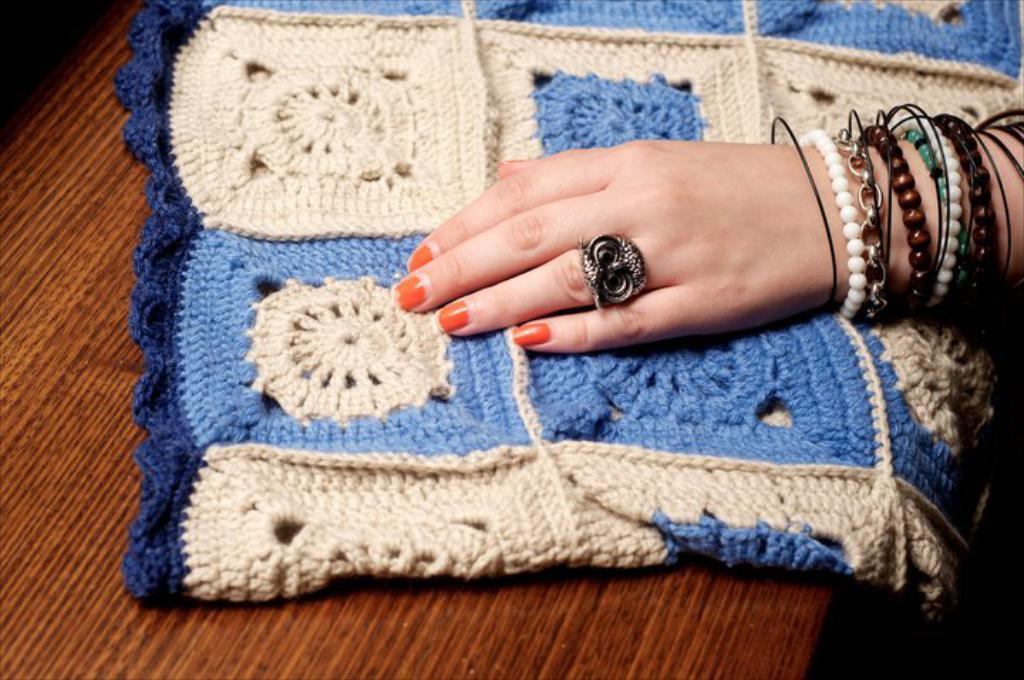How would you summarize this image in a sentence or two? In this image there is a table in the bottom of this image and there is one cloth kept on to this table, and there is one human hand on the right side of this image. 